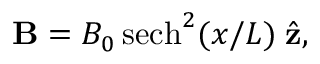Convert formula to latex. <formula><loc_0><loc_0><loc_500><loc_500>{ B } = B _ { 0 } \, s e c h ^ { 2 } ( x / L ) \, { \hat { z } } ,</formula> 